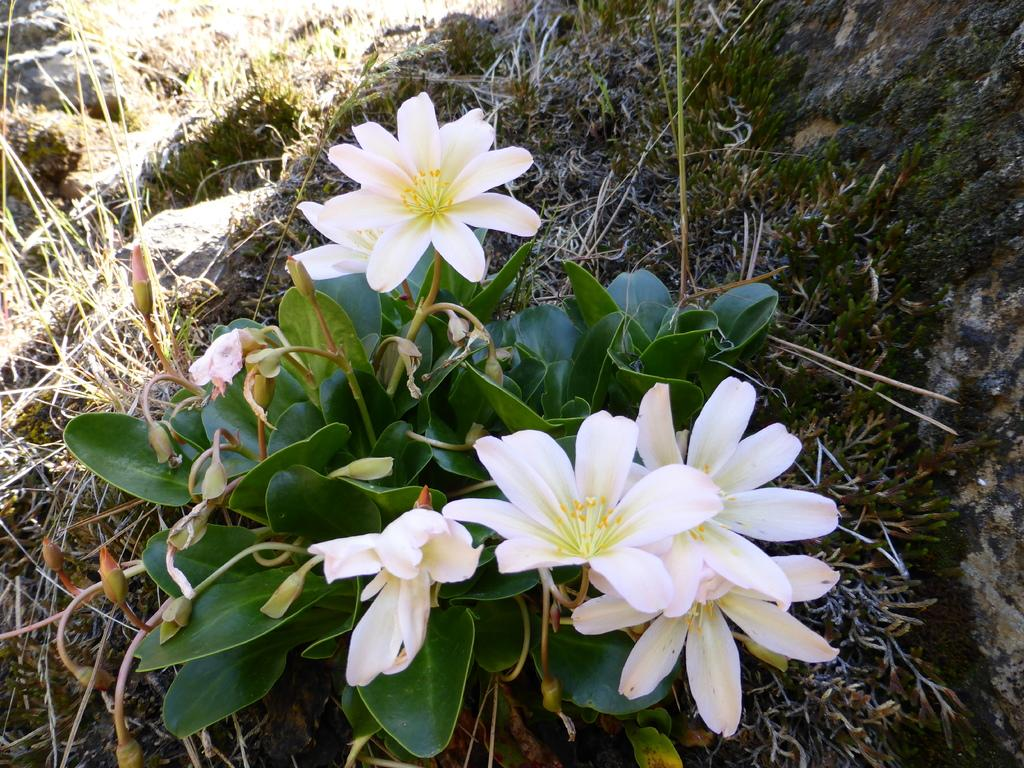What type of plant is in the image? There is a plant in the image, and it has flowers, buds, and leaves. What can be seen in the background of the image? The background of the image includes land, grass, and rocks. What type of lawyer is depicted wearing a crown in the image? There is no lawyer or crown present in the image; it features a plant with flowers, buds, and leaves, along with a background of land, grass, and rocks. 